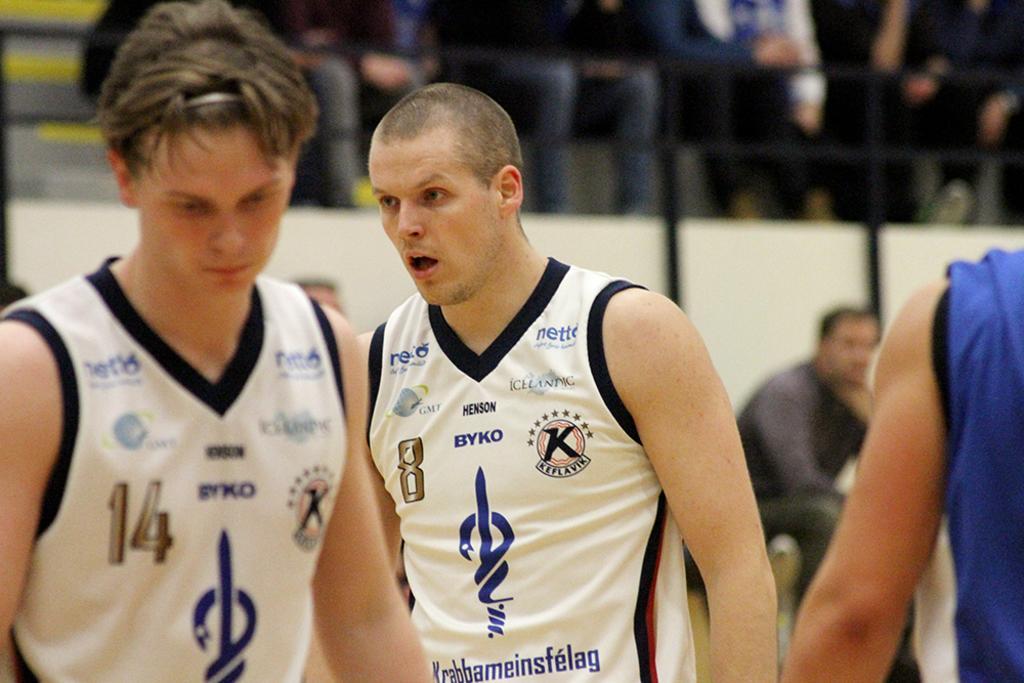Can you describe this image briefly? There are two men wearing white color dress. On the dress there is a logo, number and something is written. In the background it is blurred in the background and some people are over there. 